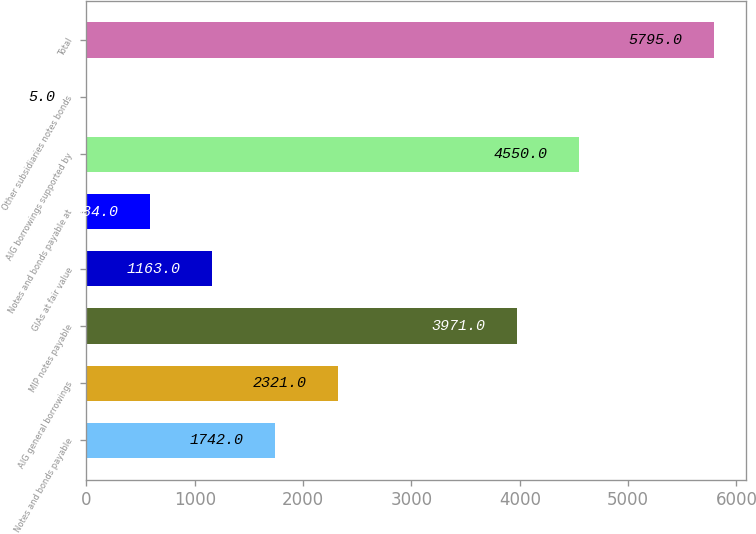Convert chart. <chart><loc_0><loc_0><loc_500><loc_500><bar_chart><fcel>Notes and bonds payable<fcel>AIG general borrowings<fcel>MIP notes payable<fcel>GIAs at fair value<fcel>Notes and bonds payable at<fcel>AIG borrowings supported by<fcel>Other subsidiaries notes bonds<fcel>Total<nl><fcel>1742<fcel>2321<fcel>3971<fcel>1163<fcel>584<fcel>4550<fcel>5<fcel>5795<nl></chart> 